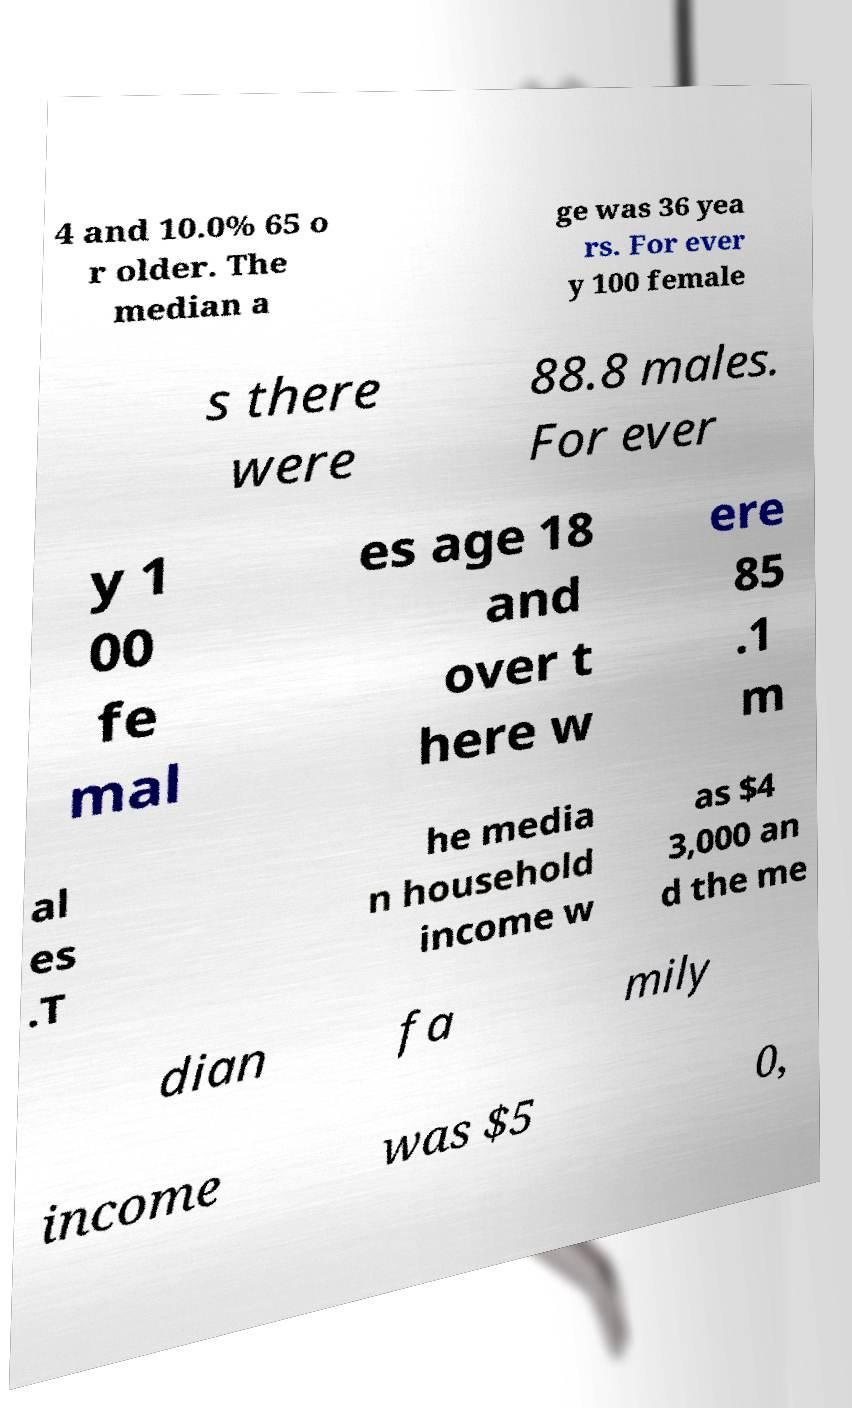Please identify and transcribe the text found in this image. 4 and 10.0% 65 o r older. The median a ge was 36 yea rs. For ever y 100 female s there were 88.8 males. For ever y 1 00 fe mal es age 18 and over t here w ere 85 .1 m al es .T he media n household income w as $4 3,000 an d the me dian fa mily income was $5 0, 